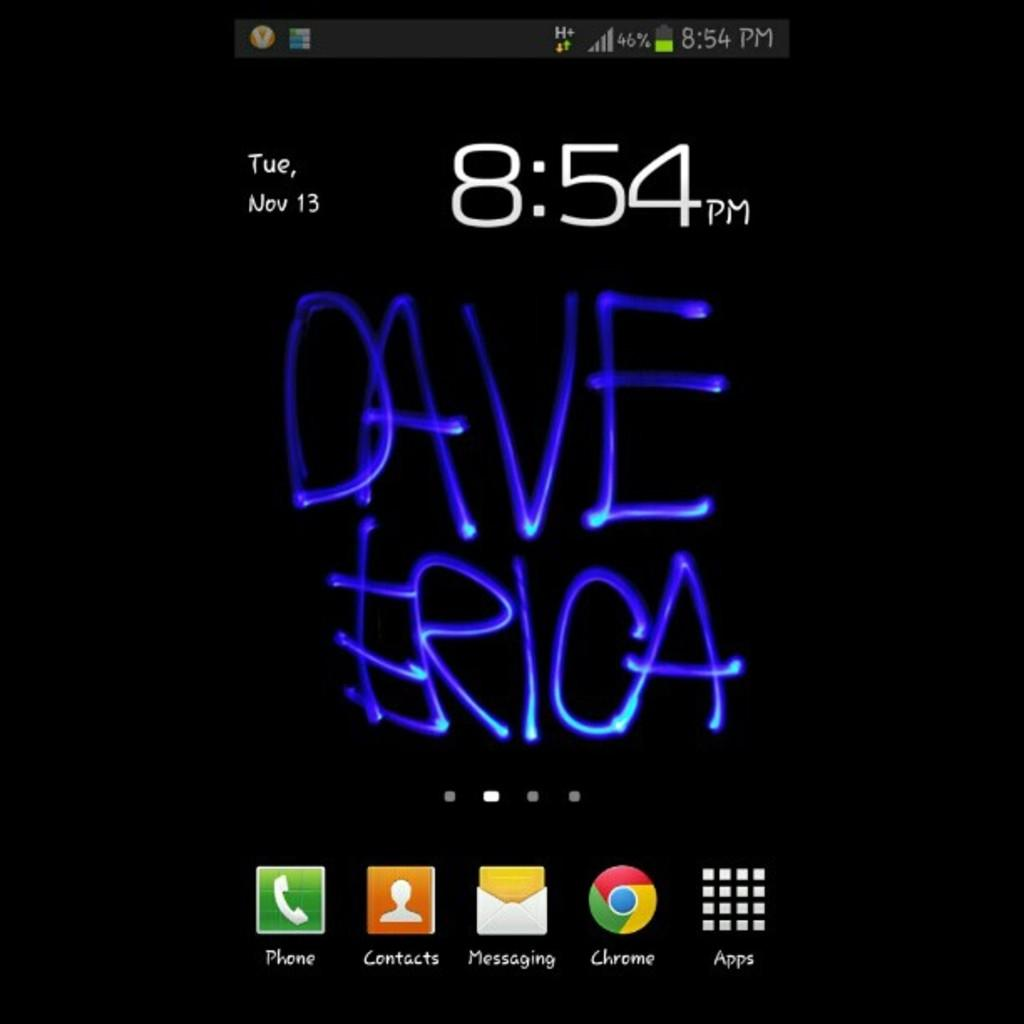<image>
Relay a brief, clear account of the picture shown. A phone screen that says Dave Erica on it shows that the time is 8:54. 